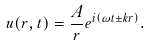<formula> <loc_0><loc_0><loc_500><loc_500>u ( r , t ) = { \frac { A } { r } } e ^ { i \left ( \omega t \pm k r \right ) } .</formula> 